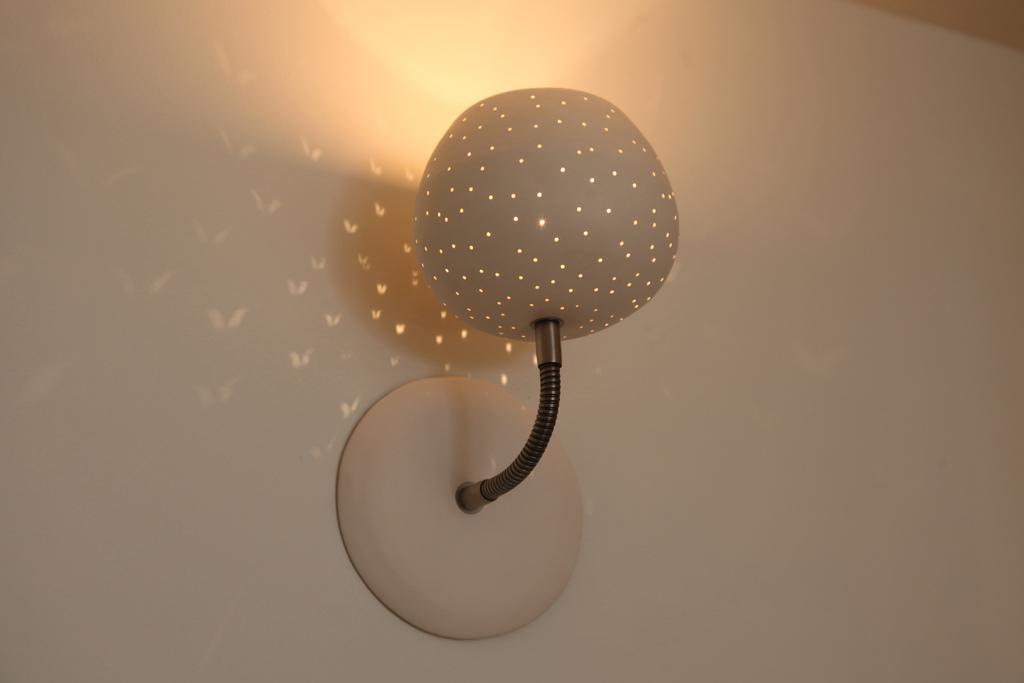Please provide a concise description of this image. In this picture there is a lamp on the wall. Here we can see the lights. 